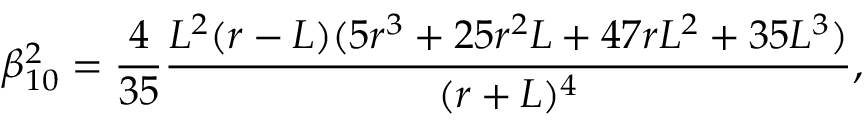Convert formula to latex. <formula><loc_0><loc_0><loc_500><loc_500>\beta _ { 1 0 } ^ { 2 } = \frac { 4 } { 3 5 } \frac { L ^ { 2 } ( r - L ) ( 5 r ^ { 3 } + 2 5 r ^ { 2 } L + 4 7 r L ^ { 2 } + 3 5 L ^ { 3 } ) } { ( r + L ) ^ { 4 } } ,</formula> 